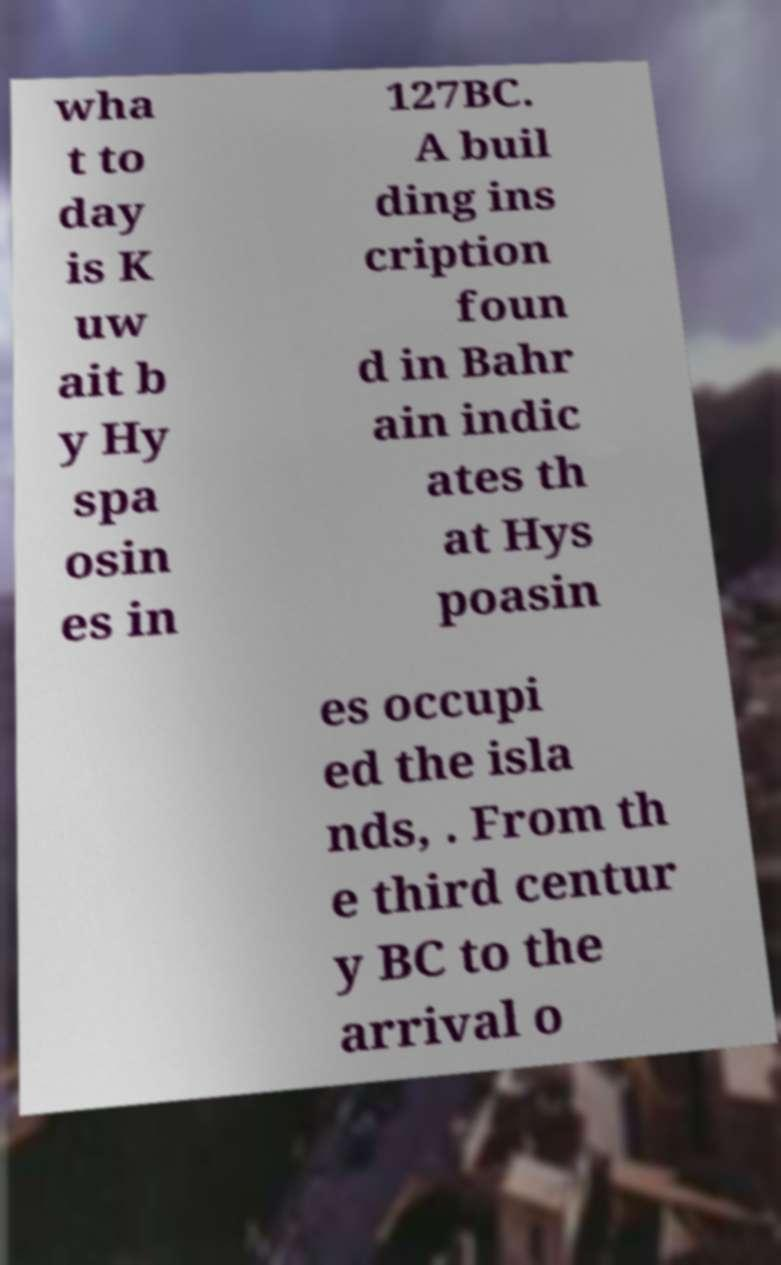Please read and relay the text visible in this image. What does it say? wha t to day is K uw ait b y Hy spa osin es in 127BC. A buil ding ins cription foun d in Bahr ain indic ates th at Hys poasin es occupi ed the isla nds, . From th e third centur y BC to the arrival o 